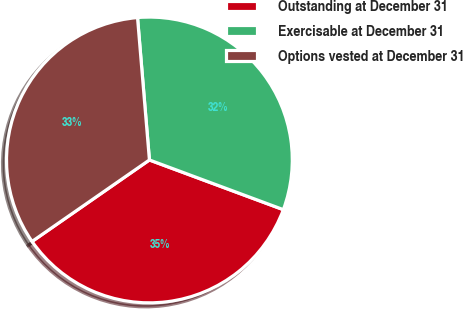<chart> <loc_0><loc_0><loc_500><loc_500><pie_chart><fcel>Outstanding at December 31<fcel>Exercisable at December 31<fcel>Options vested at December 31<nl><fcel>34.68%<fcel>31.98%<fcel>33.33%<nl></chart> 